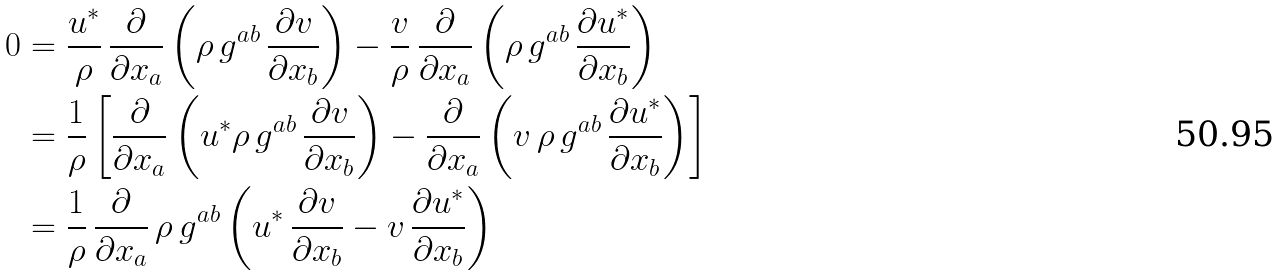<formula> <loc_0><loc_0><loc_500><loc_500>0 & = \frac { u ^ { * } } { \rho } \, \frac { \partial } { \partial x _ { a } } \left ( \rho \, g ^ { a b } \, \frac { \partial v } { \partial x _ { b } } \right ) - \frac { v } { \rho } \, \frac { \partial } { \partial x _ { a } } \left ( \rho \, g ^ { a b } \, \frac { \partial u ^ { * } } { \partial x _ { b } } \right ) \\ & = \frac { 1 } { \rho } \left [ \frac { \partial } { \partial x _ { a } } \left ( u ^ { * } \rho \, g ^ { a b } \, \frac { \partial v } { \partial x _ { b } } \right ) - \frac { \partial } { \partial x _ { a } } \left ( v \, \rho \, g ^ { a b } \, \frac { \partial u ^ { * } } { \partial x _ { b } } \right ) \right ] \\ & = \frac { 1 } { \rho } \, \frac { \partial } { \partial x _ { a } } \, \rho \, g ^ { a b } \left ( u ^ { * } \, \frac { \partial v } { \partial x _ { b } } - v \, \frac { \partial u ^ { * } } { \partial x _ { b } } \right )</formula> 